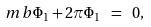Convert formula to latex. <formula><loc_0><loc_0><loc_500><loc_500>\ m b \Phi _ { 1 } + 2 \pi \Phi _ { 1 } \ = \ 0 ,</formula> 